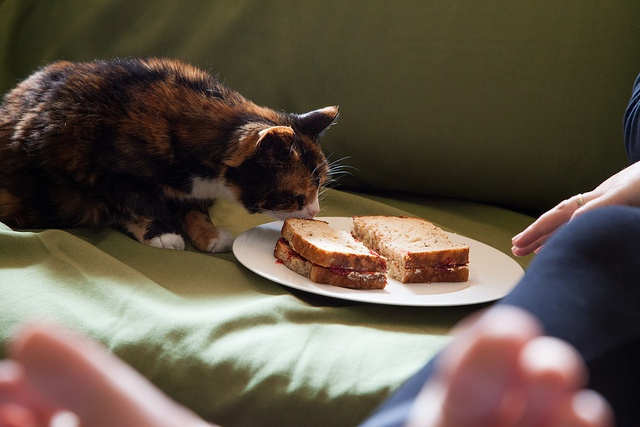Describe the objects in this image and their specific colors. I can see couch in black, darkgreen, and ivory tones, cat in black, maroon, and gray tones, people in black, brown, lightgray, and gray tones, sandwich in black, maroon, tan, and lightgray tones, and sandwich in black, maroon, brown, white, and tan tones in this image. 